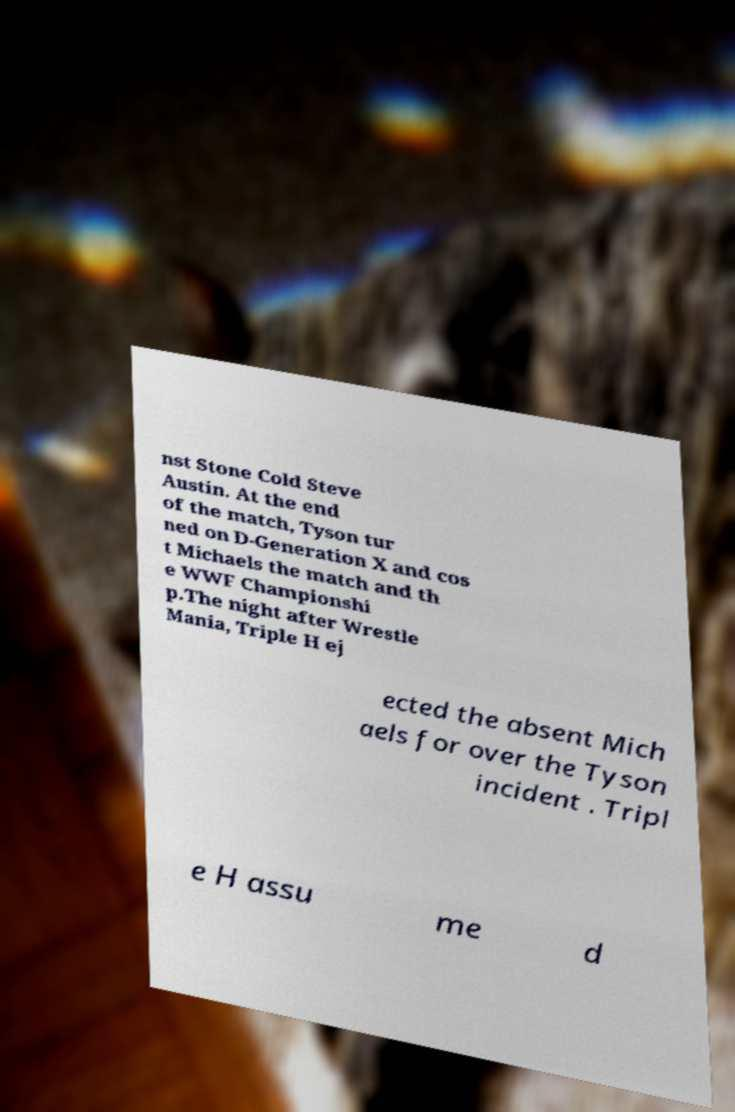Can you read and provide the text displayed in the image?This photo seems to have some interesting text. Can you extract and type it out for me? nst Stone Cold Steve Austin. At the end of the match, Tyson tur ned on D-Generation X and cos t Michaels the match and th e WWF Championshi p.The night after Wrestle Mania, Triple H ej ected the absent Mich aels for over the Tyson incident . Tripl e H assu me d 